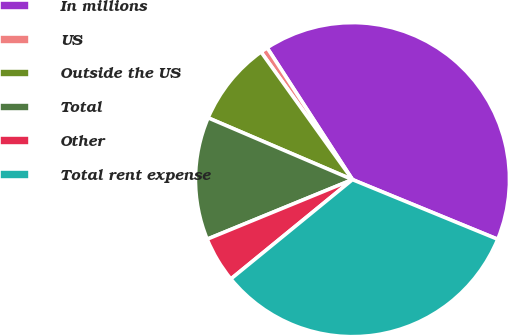Convert chart. <chart><loc_0><loc_0><loc_500><loc_500><pie_chart><fcel>In millions<fcel>US<fcel>Outside the US<fcel>Total<fcel>Other<fcel>Total rent expense<nl><fcel>40.35%<fcel>0.75%<fcel>8.67%<fcel>12.63%<fcel>4.71%<fcel>32.9%<nl></chart> 